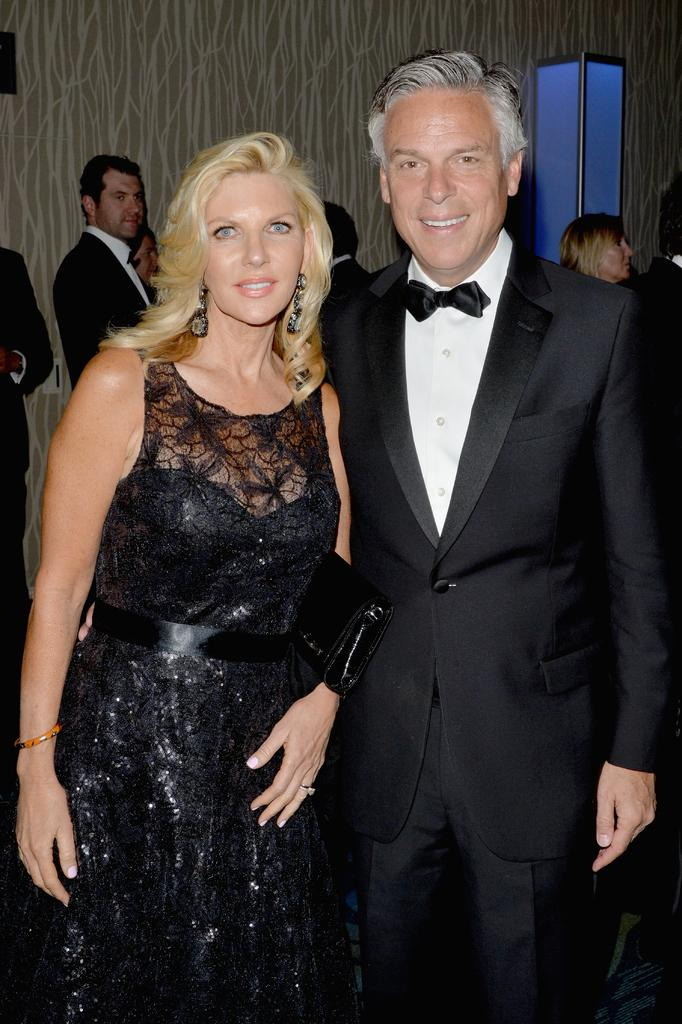How many people are in the image? There is a group of people in the image, but the exact number cannot be determined from the provided facts. What are the people in the image doing? The people are on the floor, but their specific activity is not mentioned in the facts. What can be seen in the background of the image? There is a door and a wall visible in the background of the image. Where might the image have been taken? The image may have been taken in a hall, based on the presence of a group of people and a wall in the background. What type of quiver can be seen in the image? There is no quiver present in the image. Can you tell me how many apples are on the floor in the image? The facts do not mention any apples in the image, so it is not possible to determine their number. 